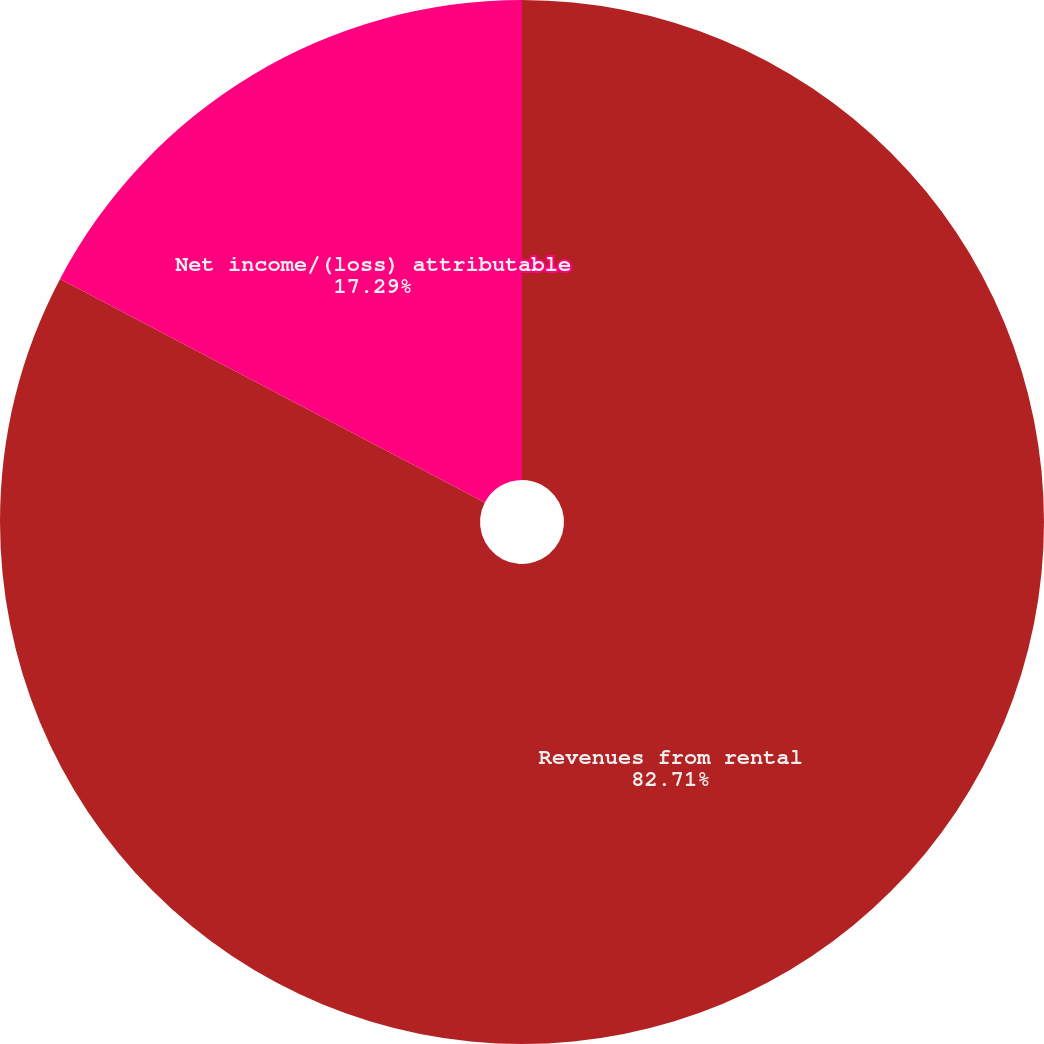<chart> <loc_0><loc_0><loc_500><loc_500><pie_chart><fcel>Revenues from rental<fcel>Net income/(loss) attributable<fcel>Basic<nl><fcel>82.71%<fcel>17.29%<fcel>0.0%<nl></chart> 